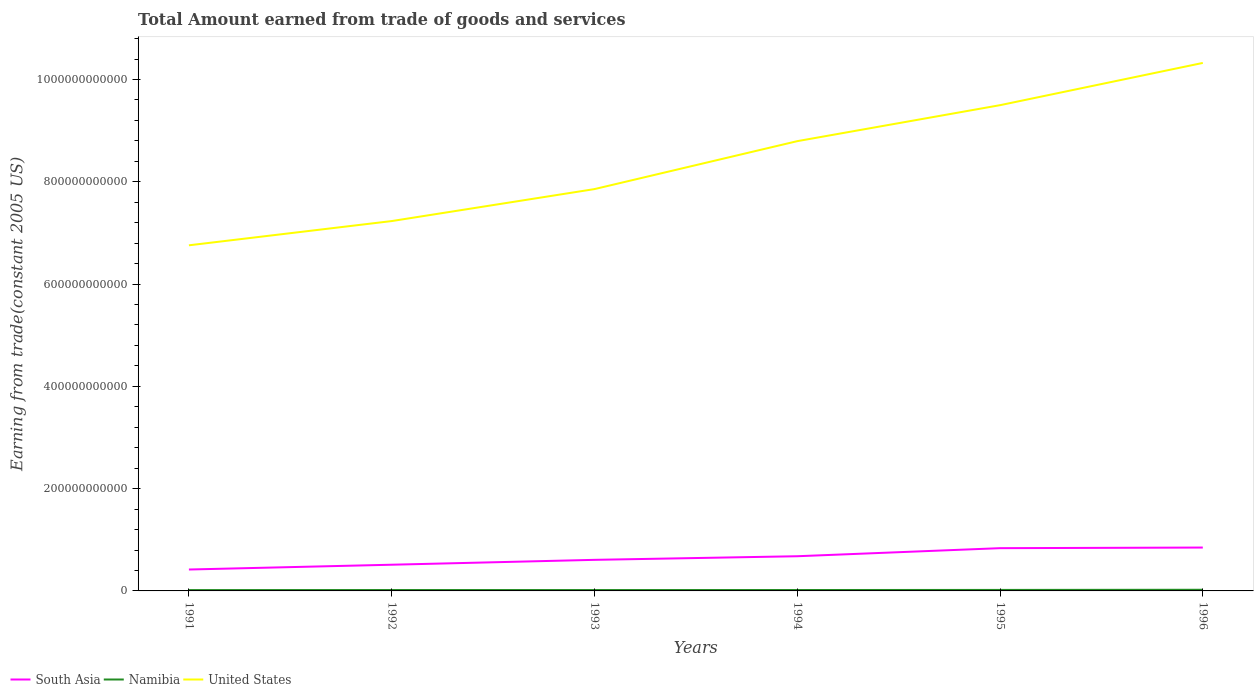Does the line corresponding to Namibia intersect with the line corresponding to South Asia?
Make the answer very short. No. Across all years, what is the maximum total amount earned by trading goods and services in Namibia?
Keep it short and to the point. 1.64e+09. In which year was the total amount earned by trading goods and services in United States maximum?
Ensure brevity in your answer.  1991. What is the total total amount earned by trading goods and services in South Asia in the graph?
Provide a succinct answer. -2.40e+1. What is the difference between the highest and the second highest total amount earned by trading goods and services in Namibia?
Offer a terse response. 6.03e+08. How many lines are there?
Offer a terse response. 3. How many years are there in the graph?
Provide a short and direct response. 6. What is the difference between two consecutive major ticks on the Y-axis?
Keep it short and to the point. 2.00e+11. Are the values on the major ticks of Y-axis written in scientific E-notation?
Provide a short and direct response. No. What is the title of the graph?
Provide a short and direct response. Total Amount earned from trade of goods and services. What is the label or title of the X-axis?
Your response must be concise. Years. What is the label or title of the Y-axis?
Your response must be concise. Earning from trade(constant 2005 US). What is the Earning from trade(constant 2005 US) of South Asia in 1991?
Your answer should be very brief. 4.19e+1. What is the Earning from trade(constant 2005 US) of Namibia in 1991?
Your answer should be very brief. 1.64e+09. What is the Earning from trade(constant 2005 US) of United States in 1991?
Your answer should be very brief. 6.76e+11. What is the Earning from trade(constant 2005 US) of South Asia in 1992?
Keep it short and to the point. 5.12e+1. What is the Earning from trade(constant 2005 US) in Namibia in 1992?
Offer a terse response. 1.73e+09. What is the Earning from trade(constant 2005 US) in United States in 1992?
Provide a short and direct response. 7.23e+11. What is the Earning from trade(constant 2005 US) of South Asia in 1993?
Provide a short and direct response. 6.08e+1. What is the Earning from trade(constant 2005 US) of Namibia in 1993?
Provide a short and direct response. 1.71e+09. What is the Earning from trade(constant 2005 US) of United States in 1993?
Provide a succinct answer. 7.86e+11. What is the Earning from trade(constant 2005 US) of South Asia in 1994?
Provide a short and direct response. 6.78e+1. What is the Earning from trade(constant 2005 US) in Namibia in 1994?
Ensure brevity in your answer.  1.78e+09. What is the Earning from trade(constant 2005 US) of United States in 1994?
Offer a very short reply. 8.79e+11. What is the Earning from trade(constant 2005 US) in South Asia in 1995?
Ensure brevity in your answer.  8.36e+1. What is the Earning from trade(constant 2005 US) in Namibia in 1995?
Your answer should be very brief. 1.94e+09. What is the Earning from trade(constant 2005 US) in United States in 1995?
Your answer should be very brief. 9.50e+11. What is the Earning from trade(constant 2005 US) in South Asia in 1996?
Your answer should be very brief. 8.48e+1. What is the Earning from trade(constant 2005 US) in Namibia in 1996?
Give a very brief answer. 2.25e+09. What is the Earning from trade(constant 2005 US) of United States in 1996?
Provide a succinct answer. 1.03e+12. Across all years, what is the maximum Earning from trade(constant 2005 US) in South Asia?
Keep it short and to the point. 8.48e+1. Across all years, what is the maximum Earning from trade(constant 2005 US) in Namibia?
Provide a succinct answer. 2.25e+09. Across all years, what is the maximum Earning from trade(constant 2005 US) in United States?
Offer a terse response. 1.03e+12. Across all years, what is the minimum Earning from trade(constant 2005 US) in South Asia?
Provide a succinct answer. 4.19e+1. Across all years, what is the minimum Earning from trade(constant 2005 US) of Namibia?
Keep it short and to the point. 1.64e+09. Across all years, what is the minimum Earning from trade(constant 2005 US) in United States?
Give a very brief answer. 6.76e+11. What is the total Earning from trade(constant 2005 US) in South Asia in the graph?
Your answer should be very brief. 3.90e+11. What is the total Earning from trade(constant 2005 US) of Namibia in the graph?
Your response must be concise. 1.11e+1. What is the total Earning from trade(constant 2005 US) in United States in the graph?
Keep it short and to the point. 5.05e+12. What is the difference between the Earning from trade(constant 2005 US) of South Asia in 1991 and that in 1992?
Keep it short and to the point. -9.35e+09. What is the difference between the Earning from trade(constant 2005 US) in Namibia in 1991 and that in 1992?
Your answer should be very brief. -8.85e+07. What is the difference between the Earning from trade(constant 2005 US) of United States in 1991 and that in 1992?
Ensure brevity in your answer.  -4.74e+1. What is the difference between the Earning from trade(constant 2005 US) in South Asia in 1991 and that in 1993?
Provide a short and direct response. -1.89e+1. What is the difference between the Earning from trade(constant 2005 US) of Namibia in 1991 and that in 1993?
Provide a succinct answer. -7.15e+07. What is the difference between the Earning from trade(constant 2005 US) in United States in 1991 and that in 1993?
Your answer should be compact. -1.10e+11. What is the difference between the Earning from trade(constant 2005 US) in South Asia in 1991 and that in 1994?
Give a very brief answer. -2.60e+1. What is the difference between the Earning from trade(constant 2005 US) of Namibia in 1991 and that in 1994?
Your answer should be very brief. -1.36e+08. What is the difference between the Earning from trade(constant 2005 US) in United States in 1991 and that in 1994?
Keep it short and to the point. -2.04e+11. What is the difference between the Earning from trade(constant 2005 US) in South Asia in 1991 and that in 1995?
Your answer should be compact. -4.17e+1. What is the difference between the Earning from trade(constant 2005 US) in Namibia in 1991 and that in 1995?
Offer a very short reply. -2.98e+08. What is the difference between the Earning from trade(constant 2005 US) of United States in 1991 and that in 1995?
Offer a terse response. -2.74e+11. What is the difference between the Earning from trade(constant 2005 US) of South Asia in 1991 and that in 1996?
Your answer should be very brief. -4.29e+1. What is the difference between the Earning from trade(constant 2005 US) in Namibia in 1991 and that in 1996?
Your answer should be compact. -6.03e+08. What is the difference between the Earning from trade(constant 2005 US) in United States in 1991 and that in 1996?
Ensure brevity in your answer.  -3.57e+11. What is the difference between the Earning from trade(constant 2005 US) in South Asia in 1992 and that in 1993?
Make the answer very short. -9.54e+09. What is the difference between the Earning from trade(constant 2005 US) in Namibia in 1992 and that in 1993?
Provide a short and direct response. 1.70e+07. What is the difference between the Earning from trade(constant 2005 US) in United States in 1992 and that in 1993?
Offer a very short reply. -6.25e+1. What is the difference between the Earning from trade(constant 2005 US) in South Asia in 1992 and that in 1994?
Offer a very short reply. -1.66e+1. What is the difference between the Earning from trade(constant 2005 US) of Namibia in 1992 and that in 1994?
Your response must be concise. -4.72e+07. What is the difference between the Earning from trade(constant 2005 US) of United States in 1992 and that in 1994?
Your response must be concise. -1.56e+11. What is the difference between the Earning from trade(constant 2005 US) of South Asia in 1992 and that in 1995?
Make the answer very short. -3.24e+1. What is the difference between the Earning from trade(constant 2005 US) in Namibia in 1992 and that in 1995?
Give a very brief answer. -2.10e+08. What is the difference between the Earning from trade(constant 2005 US) of United States in 1992 and that in 1995?
Provide a short and direct response. -2.27e+11. What is the difference between the Earning from trade(constant 2005 US) in South Asia in 1992 and that in 1996?
Give a very brief answer. -3.36e+1. What is the difference between the Earning from trade(constant 2005 US) in Namibia in 1992 and that in 1996?
Give a very brief answer. -5.14e+08. What is the difference between the Earning from trade(constant 2005 US) in United States in 1992 and that in 1996?
Offer a terse response. -3.09e+11. What is the difference between the Earning from trade(constant 2005 US) in South Asia in 1993 and that in 1994?
Your answer should be very brief. -7.07e+09. What is the difference between the Earning from trade(constant 2005 US) in Namibia in 1993 and that in 1994?
Provide a short and direct response. -6.41e+07. What is the difference between the Earning from trade(constant 2005 US) in United States in 1993 and that in 1994?
Provide a short and direct response. -9.37e+1. What is the difference between the Earning from trade(constant 2005 US) of South Asia in 1993 and that in 1995?
Offer a very short reply. -2.28e+1. What is the difference between the Earning from trade(constant 2005 US) in Namibia in 1993 and that in 1995?
Offer a very short reply. -2.27e+08. What is the difference between the Earning from trade(constant 2005 US) of United States in 1993 and that in 1995?
Provide a short and direct response. -1.64e+11. What is the difference between the Earning from trade(constant 2005 US) in South Asia in 1993 and that in 1996?
Make the answer very short. -2.40e+1. What is the difference between the Earning from trade(constant 2005 US) of Namibia in 1993 and that in 1996?
Make the answer very short. -5.31e+08. What is the difference between the Earning from trade(constant 2005 US) in United States in 1993 and that in 1996?
Give a very brief answer. -2.47e+11. What is the difference between the Earning from trade(constant 2005 US) of South Asia in 1994 and that in 1995?
Ensure brevity in your answer.  -1.58e+1. What is the difference between the Earning from trade(constant 2005 US) of Namibia in 1994 and that in 1995?
Keep it short and to the point. -1.62e+08. What is the difference between the Earning from trade(constant 2005 US) of United States in 1994 and that in 1995?
Make the answer very short. -7.04e+1. What is the difference between the Earning from trade(constant 2005 US) in South Asia in 1994 and that in 1996?
Give a very brief answer. -1.70e+1. What is the difference between the Earning from trade(constant 2005 US) of Namibia in 1994 and that in 1996?
Offer a very short reply. -4.67e+08. What is the difference between the Earning from trade(constant 2005 US) in United States in 1994 and that in 1996?
Your answer should be compact. -1.53e+11. What is the difference between the Earning from trade(constant 2005 US) of South Asia in 1995 and that in 1996?
Keep it short and to the point. -1.20e+09. What is the difference between the Earning from trade(constant 2005 US) of Namibia in 1995 and that in 1996?
Offer a very short reply. -3.05e+08. What is the difference between the Earning from trade(constant 2005 US) in United States in 1995 and that in 1996?
Your answer should be very brief. -8.26e+1. What is the difference between the Earning from trade(constant 2005 US) in South Asia in 1991 and the Earning from trade(constant 2005 US) in Namibia in 1992?
Offer a terse response. 4.01e+1. What is the difference between the Earning from trade(constant 2005 US) of South Asia in 1991 and the Earning from trade(constant 2005 US) of United States in 1992?
Your response must be concise. -6.81e+11. What is the difference between the Earning from trade(constant 2005 US) in Namibia in 1991 and the Earning from trade(constant 2005 US) in United States in 1992?
Give a very brief answer. -7.22e+11. What is the difference between the Earning from trade(constant 2005 US) in South Asia in 1991 and the Earning from trade(constant 2005 US) in Namibia in 1993?
Your answer should be compact. 4.02e+1. What is the difference between the Earning from trade(constant 2005 US) of South Asia in 1991 and the Earning from trade(constant 2005 US) of United States in 1993?
Offer a terse response. -7.44e+11. What is the difference between the Earning from trade(constant 2005 US) in Namibia in 1991 and the Earning from trade(constant 2005 US) in United States in 1993?
Offer a very short reply. -7.84e+11. What is the difference between the Earning from trade(constant 2005 US) of South Asia in 1991 and the Earning from trade(constant 2005 US) of Namibia in 1994?
Keep it short and to the point. 4.01e+1. What is the difference between the Earning from trade(constant 2005 US) of South Asia in 1991 and the Earning from trade(constant 2005 US) of United States in 1994?
Make the answer very short. -8.38e+11. What is the difference between the Earning from trade(constant 2005 US) of Namibia in 1991 and the Earning from trade(constant 2005 US) of United States in 1994?
Make the answer very short. -8.78e+11. What is the difference between the Earning from trade(constant 2005 US) of South Asia in 1991 and the Earning from trade(constant 2005 US) of Namibia in 1995?
Your answer should be very brief. 3.99e+1. What is the difference between the Earning from trade(constant 2005 US) in South Asia in 1991 and the Earning from trade(constant 2005 US) in United States in 1995?
Your answer should be compact. -9.08e+11. What is the difference between the Earning from trade(constant 2005 US) of Namibia in 1991 and the Earning from trade(constant 2005 US) of United States in 1995?
Your answer should be compact. -9.48e+11. What is the difference between the Earning from trade(constant 2005 US) of South Asia in 1991 and the Earning from trade(constant 2005 US) of Namibia in 1996?
Give a very brief answer. 3.96e+1. What is the difference between the Earning from trade(constant 2005 US) of South Asia in 1991 and the Earning from trade(constant 2005 US) of United States in 1996?
Give a very brief answer. -9.91e+11. What is the difference between the Earning from trade(constant 2005 US) in Namibia in 1991 and the Earning from trade(constant 2005 US) in United States in 1996?
Keep it short and to the point. -1.03e+12. What is the difference between the Earning from trade(constant 2005 US) of South Asia in 1992 and the Earning from trade(constant 2005 US) of Namibia in 1993?
Give a very brief answer. 4.95e+1. What is the difference between the Earning from trade(constant 2005 US) in South Asia in 1992 and the Earning from trade(constant 2005 US) in United States in 1993?
Provide a short and direct response. -7.34e+11. What is the difference between the Earning from trade(constant 2005 US) in Namibia in 1992 and the Earning from trade(constant 2005 US) in United States in 1993?
Your answer should be very brief. -7.84e+11. What is the difference between the Earning from trade(constant 2005 US) in South Asia in 1992 and the Earning from trade(constant 2005 US) in Namibia in 1994?
Ensure brevity in your answer.  4.94e+1. What is the difference between the Earning from trade(constant 2005 US) of South Asia in 1992 and the Earning from trade(constant 2005 US) of United States in 1994?
Ensure brevity in your answer.  -8.28e+11. What is the difference between the Earning from trade(constant 2005 US) in Namibia in 1992 and the Earning from trade(constant 2005 US) in United States in 1994?
Make the answer very short. -8.78e+11. What is the difference between the Earning from trade(constant 2005 US) in South Asia in 1992 and the Earning from trade(constant 2005 US) in Namibia in 1995?
Your answer should be compact. 4.93e+1. What is the difference between the Earning from trade(constant 2005 US) of South Asia in 1992 and the Earning from trade(constant 2005 US) of United States in 1995?
Make the answer very short. -8.99e+11. What is the difference between the Earning from trade(constant 2005 US) of Namibia in 1992 and the Earning from trade(constant 2005 US) of United States in 1995?
Your response must be concise. -9.48e+11. What is the difference between the Earning from trade(constant 2005 US) in South Asia in 1992 and the Earning from trade(constant 2005 US) in Namibia in 1996?
Give a very brief answer. 4.90e+1. What is the difference between the Earning from trade(constant 2005 US) of South Asia in 1992 and the Earning from trade(constant 2005 US) of United States in 1996?
Make the answer very short. -9.81e+11. What is the difference between the Earning from trade(constant 2005 US) in Namibia in 1992 and the Earning from trade(constant 2005 US) in United States in 1996?
Provide a succinct answer. -1.03e+12. What is the difference between the Earning from trade(constant 2005 US) in South Asia in 1993 and the Earning from trade(constant 2005 US) in Namibia in 1994?
Make the answer very short. 5.90e+1. What is the difference between the Earning from trade(constant 2005 US) in South Asia in 1993 and the Earning from trade(constant 2005 US) in United States in 1994?
Your answer should be compact. -8.19e+11. What is the difference between the Earning from trade(constant 2005 US) in Namibia in 1993 and the Earning from trade(constant 2005 US) in United States in 1994?
Ensure brevity in your answer.  -8.78e+11. What is the difference between the Earning from trade(constant 2005 US) of South Asia in 1993 and the Earning from trade(constant 2005 US) of Namibia in 1995?
Keep it short and to the point. 5.88e+1. What is the difference between the Earning from trade(constant 2005 US) in South Asia in 1993 and the Earning from trade(constant 2005 US) in United States in 1995?
Keep it short and to the point. -8.89e+11. What is the difference between the Earning from trade(constant 2005 US) of Namibia in 1993 and the Earning from trade(constant 2005 US) of United States in 1995?
Make the answer very short. -9.48e+11. What is the difference between the Earning from trade(constant 2005 US) in South Asia in 1993 and the Earning from trade(constant 2005 US) in Namibia in 1996?
Offer a terse response. 5.85e+1. What is the difference between the Earning from trade(constant 2005 US) of South Asia in 1993 and the Earning from trade(constant 2005 US) of United States in 1996?
Keep it short and to the point. -9.72e+11. What is the difference between the Earning from trade(constant 2005 US) in Namibia in 1993 and the Earning from trade(constant 2005 US) in United States in 1996?
Give a very brief answer. -1.03e+12. What is the difference between the Earning from trade(constant 2005 US) in South Asia in 1994 and the Earning from trade(constant 2005 US) in Namibia in 1995?
Your answer should be compact. 6.59e+1. What is the difference between the Earning from trade(constant 2005 US) in South Asia in 1994 and the Earning from trade(constant 2005 US) in United States in 1995?
Your answer should be very brief. -8.82e+11. What is the difference between the Earning from trade(constant 2005 US) in Namibia in 1994 and the Earning from trade(constant 2005 US) in United States in 1995?
Your response must be concise. -9.48e+11. What is the difference between the Earning from trade(constant 2005 US) of South Asia in 1994 and the Earning from trade(constant 2005 US) of Namibia in 1996?
Your answer should be very brief. 6.56e+1. What is the difference between the Earning from trade(constant 2005 US) in South Asia in 1994 and the Earning from trade(constant 2005 US) in United States in 1996?
Give a very brief answer. -9.65e+11. What is the difference between the Earning from trade(constant 2005 US) in Namibia in 1994 and the Earning from trade(constant 2005 US) in United States in 1996?
Offer a very short reply. -1.03e+12. What is the difference between the Earning from trade(constant 2005 US) in South Asia in 1995 and the Earning from trade(constant 2005 US) in Namibia in 1996?
Provide a short and direct response. 8.14e+1. What is the difference between the Earning from trade(constant 2005 US) of South Asia in 1995 and the Earning from trade(constant 2005 US) of United States in 1996?
Ensure brevity in your answer.  -9.49e+11. What is the difference between the Earning from trade(constant 2005 US) in Namibia in 1995 and the Earning from trade(constant 2005 US) in United States in 1996?
Ensure brevity in your answer.  -1.03e+12. What is the average Earning from trade(constant 2005 US) in South Asia per year?
Ensure brevity in your answer.  6.50e+1. What is the average Earning from trade(constant 2005 US) of Namibia per year?
Your response must be concise. 1.84e+09. What is the average Earning from trade(constant 2005 US) in United States per year?
Make the answer very short. 8.41e+11. In the year 1991, what is the difference between the Earning from trade(constant 2005 US) of South Asia and Earning from trade(constant 2005 US) of Namibia?
Offer a very short reply. 4.02e+1. In the year 1991, what is the difference between the Earning from trade(constant 2005 US) in South Asia and Earning from trade(constant 2005 US) in United States?
Provide a short and direct response. -6.34e+11. In the year 1991, what is the difference between the Earning from trade(constant 2005 US) of Namibia and Earning from trade(constant 2005 US) of United States?
Offer a very short reply. -6.74e+11. In the year 1992, what is the difference between the Earning from trade(constant 2005 US) of South Asia and Earning from trade(constant 2005 US) of Namibia?
Provide a short and direct response. 4.95e+1. In the year 1992, what is the difference between the Earning from trade(constant 2005 US) of South Asia and Earning from trade(constant 2005 US) of United States?
Provide a succinct answer. -6.72e+11. In the year 1992, what is the difference between the Earning from trade(constant 2005 US) of Namibia and Earning from trade(constant 2005 US) of United States?
Your response must be concise. -7.21e+11. In the year 1993, what is the difference between the Earning from trade(constant 2005 US) of South Asia and Earning from trade(constant 2005 US) of Namibia?
Your answer should be very brief. 5.90e+1. In the year 1993, what is the difference between the Earning from trade(constant 2005 US) in South Asia and Earning from trade(constant 2005 US) in United States?
Ensure brevity in your answer.  -7.25e+11. In the year 1993, what is the difference between the Earning from trade(constant 2005 US) of Namibia and Earning from trade(constant 2005 US) of United States?
Make the answer very short. -7.84e+11. In the year 1994, what is the difference between the Earning from trade(constant 2005 US) of South Asia and Earning from trade(constant 2005 US) of Namibia?
Provide a succinct answer. 6.61e+1. In the year 1994, what is the difference between the Earning from trade(constant 2005 US) of South Asia and Earning from trade(constant 2005 US) of United States?
Keep it short and to the point. -8.12e+11. In the year 1994, what is the difference between the Earning from trade(constant 2005 US) in Namibia and Earning from trade(constant 2005 US) in United States?
Your answer should be very brief. -8.78e+11. In the year 1995, what is the difference between the Earning from trade(constant 2005 US) of South Asia and Earning from trade(constant 2005 US) of Namibia?
Make the answer very short. 8.17e+1. In the year 1995, what is the difference between the Earning from trade(constant 2005 US) in South Asia and Earning from trade(constant 2005 US) in United States?
Give a very brief answer. -8.66e+11. In the year 1995, what is the difference between the Earning from trade(constant 2005 US) in Namibia and Earning from trade(constant 2005 US) in United States?
Your answer should be compact. -9.48e+11. In the year 1996, what is the difference between the Earning from trade(constant 2005 US) in South Asia and Earning from trade(constant 2005 US) in Namibia?
Offer a terse response. 8.26e+1. In the year 1996, what is the difference between the Earning from trade(constant 2005 US) in South Asia and Earning from trade(constant 2005 US) in United States?
Make the answer very short. -9.48e+11. In the year 1996, what is the difference between the Earning from trade(constant 2005 US) of Namibia and Earning from trade(constant 2005 US) of United States?
Provide a short and direct response. -1.03e+12. What is the ratio of the Earning from trade(constant 2005 US) of South Asia in 1991 to that in 1992?
Ensure brevity in your answer.  0.82. What is the ratio of the Earning from trade(constant 2005 US) in Namibia in 1991 to that in 1992?
Offer a very short reply. 0.95. What is the ratio of the Earning from trade(constant 2005 US) of United States in 1991 to that in 1992?
Ensure brevity in your answer.  0.93. What is the ratio of the Earning from trade(constant 2005 US) of South Asia in 1991 to that in 1993?
Offer a terse response. 0.69. What is the ratio of the Earning from trade(constant 2005 US) in United States in 1991 to that in 1993?
Your response must be concise. 0.86. What is the ratio of the Earning from trade(constant 2005 US) in South Asia in 1991 to that in 1994?
Your answer should be compact. 0.62. What is the ratio of the Earning from trade(constant 2005 US) in Namibia in 1991 to that in 1994?
Offer a very short reply. 0.92. What is the ratio of the Earning from trade(constant 2005 US) in United States in 1991 to that in 1994?
Ensure brevity in your answer.  0.77. What is the ratio of the Earning from trade(constant 2005 US) in South Asia in 1991 to that in 1995?
Give a very brief answer. 0.5. What is the ratio of the Earning from trade(constant 2005 US) of Namibia in 1991 to that in 1995?
Make the answer very short. 0.85. What is the ratio of the Earning from trade(constant 2005 US) of United States in 1991 to that in 1995?
Give a very brief answer. 0.71. What is the ratio of the Earning from trade(constant 2005 US) in South Asia in 1991 to that in 1996?
Your response must be concise. 0.49. What is the ratio of the Earning from trade(constant 2005 US) of Namibia in 1991 to that in 1996?
Provide a short and direct response. 0.73. What is the ratio of the Earning from trade(constant 2005 US) in United States in 1991 to that in 1996?
Ensure brevity in your answer.  0.65. What is the ratio of the Earning from trade(constant 2005 US) in South Asia in 1992 to that in 1993?
Keep it short and to the point. 0.84. What is the ratio of the Earning from trade(constant 2005 US) of Namibia in 1992 to that in 1993?
Ensure brevity in your answer.  1.01. What is the ratio of the Earning from trade(constant 2005 US) in United States in 1992 to that in 1993?
Make the answer very short. 0.92. What is the ratio of the Earning from trade(constant 2005 US) of South Asia in 1992 to that in 1994?
Make the answer very short. 0.76. What is the ratio of the Earning from trade(constant 2005 US) in Namibia in 1992 to that in 1994?
Your response must be concise. 0.97. What is the ratio of the Earning from trade(constant 2005 US) in United States in 1992 to that in 1994?
Provide a short and direct response. 0.82. What is the ratio of the Earning from trade(constant 2005 US) in South Asia in 1992 to that in 1995?
Your answer should be compact. 0.61. What is the ratio of the Earning from trade(constant 2005 US) in Namibia in 1992 to that in 1995?
Provide a succinct answer. 0.89. What is the ratio of the Earning from trade(constant 2005 US) in United States in 1992 to that in 1995?
Keep it short and to the point. 0.76. What is the ratio of the Earning from trade(constant 2005 US) of South Asia in 1992 to that in 1996?
Offer a terse response. 0.6. What is the ratio of the Earning from trade(constant 2005 US) in Namibia in 1992 to that in 1996?
Offer a terse response. 0.77. What is the ratio of the Earning from trade(constant 2005 US) of United States in 1992 to that in 1996?
Make the answer very short. 0.7. What is the ratio of the Earning from trade(constant 2005 US) of South Asia in 1993 to that in 1994?
Give a very brief answer. 0.9. What is the ratio of the Earning from trade(constant 2005 US) in Namibia in 1993 to that in 1994?
Provide a succinct answer. 0.96. What is the ratio of the Earning from trade(constant 2005 US) in United States in 1993 to that in 1994?
Keep it short and to the point. 0.89. What is the ratio of the Earning from trade(constant 2005 US) in South Asia in 1993 to that in 1995?
Offer a terse response. 0.73. What is the ratio of the Earning from trade(constant 2005 US) in Namibia in 1993 to that in 1995?
Your response must be concise. 0.88. What is the ratio of the Earning from trade(constant 2005 US) of United States in 1993 to that in 1995?
Give a very brief answer. 0.83. What is the ratio of the Earning from trade(constant 2005 US) in South Asia in 1993 to that in 1996?
Offer a terse response. 0.72. What is the ratio of the Earning from trade(constant 2005 US) in Namibia in 1993 to that in 1996?
Ensure brevity in your answer.  0.76. What is the ratio of the Earning from trade(constant 2005 US) in United States in 1993 to that in 1996?
Ensure brevity in your answer.  0.76. What is the ratio of the Earning from trade(constant 2005 US) of South Asia in 1994 to that in 1995?
Your answer should be very brief. 0.81. What is the ratio of the Earning from trade(constant 2005 US) of Namibia in 1994 to that in 1995?
Offer a terse response. 0.92. What is the ratio of the Earning from trade(constant 2005 US) in United States in 1994 to that in 1995?
Your answer should be compact. 0.93. What is the ratio of the Earning from trade(constant 2005 US) of South Asia in 1994 to that in 1996?
Offer a terse response. 0.8. What is the ratio of the Earning from trade(constant 2005 US) of Namibia in 1994 to that in 1996?
Make the answer very short. 0.79. What is the ratio of the Earning from trade(constant 2005 US) in United States in 1994 to that in 1996?
Your response must be concise. 0.85. What is the ratio of the Earning from trade(constant 2005 US) in South Asia in 1995 to that in 1996?
Offer a terse response. 0.99. What is the ratio of the Earning from trade(constant 2005 US) of Namibia in 1995 to that in 1996?
Make the answer very short. 0.86. What is the ratio of the Earning from trade(constant 2005 US) of United States in 1995 to that in 1996?
Offer a terse response. 0.92. What is the difference between the highest and the second highest Earning from trade(constant 2005 US) of South Asia?
Provide a succinct answer. 1.20e+09. What is the difference between the highest and the second highest Earning from trade(constant 2005 US) in Namibia?
Offer a very short reply. 3.05e+08. What is the difference between the highest and the second highest Earning from trade(constant 2005 US) of United States?
Offer a terse response. 8.26e+1. What is the difference between the highest and the lowest Earning from trade(constant 2005 US) in South Asia?
Offer a terse response. 4.29e+1. What is the difference between the highest and the lowest Earning from trade(constant 2005 US) in Namibia?
Your answer should be compact. 6.03e+08. What is the difference between the highest and the lowest Earning from trade(constant 2005 US) in United States?
Keep it short and to the point. 3.57e+11. 